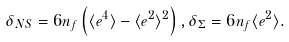<formula> <loc_0><loc_0><loc_500><loc_500>\delta _ { N S } = 6 n _ { f } \left ( \langle e ^ { 4 } \rangle - \langle e ^ { 2 } \rangle ^ { 2 } \right ) , \delta _ { \Sigma } = 6 n _ { f } \langle e ^ { 2 } \rangle .</formula> 